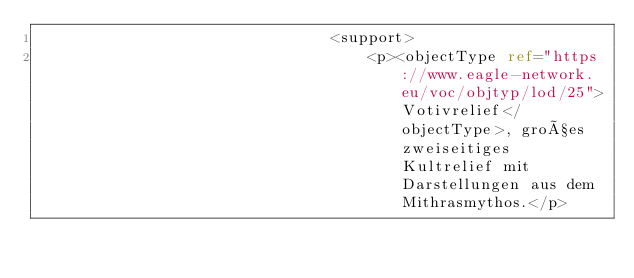<code> <loc_0><loc_0><loc_500><loc_500><_XML_>                                <support>
                                    <p><objectType ref="https://www.eagle-network.eu/voc/objtyp/lod/25">Votivrelief</objectType>, großes zweiseitiges Kultrelief mit Darstellungen aus dem Mithrasmythos.</p></code> 